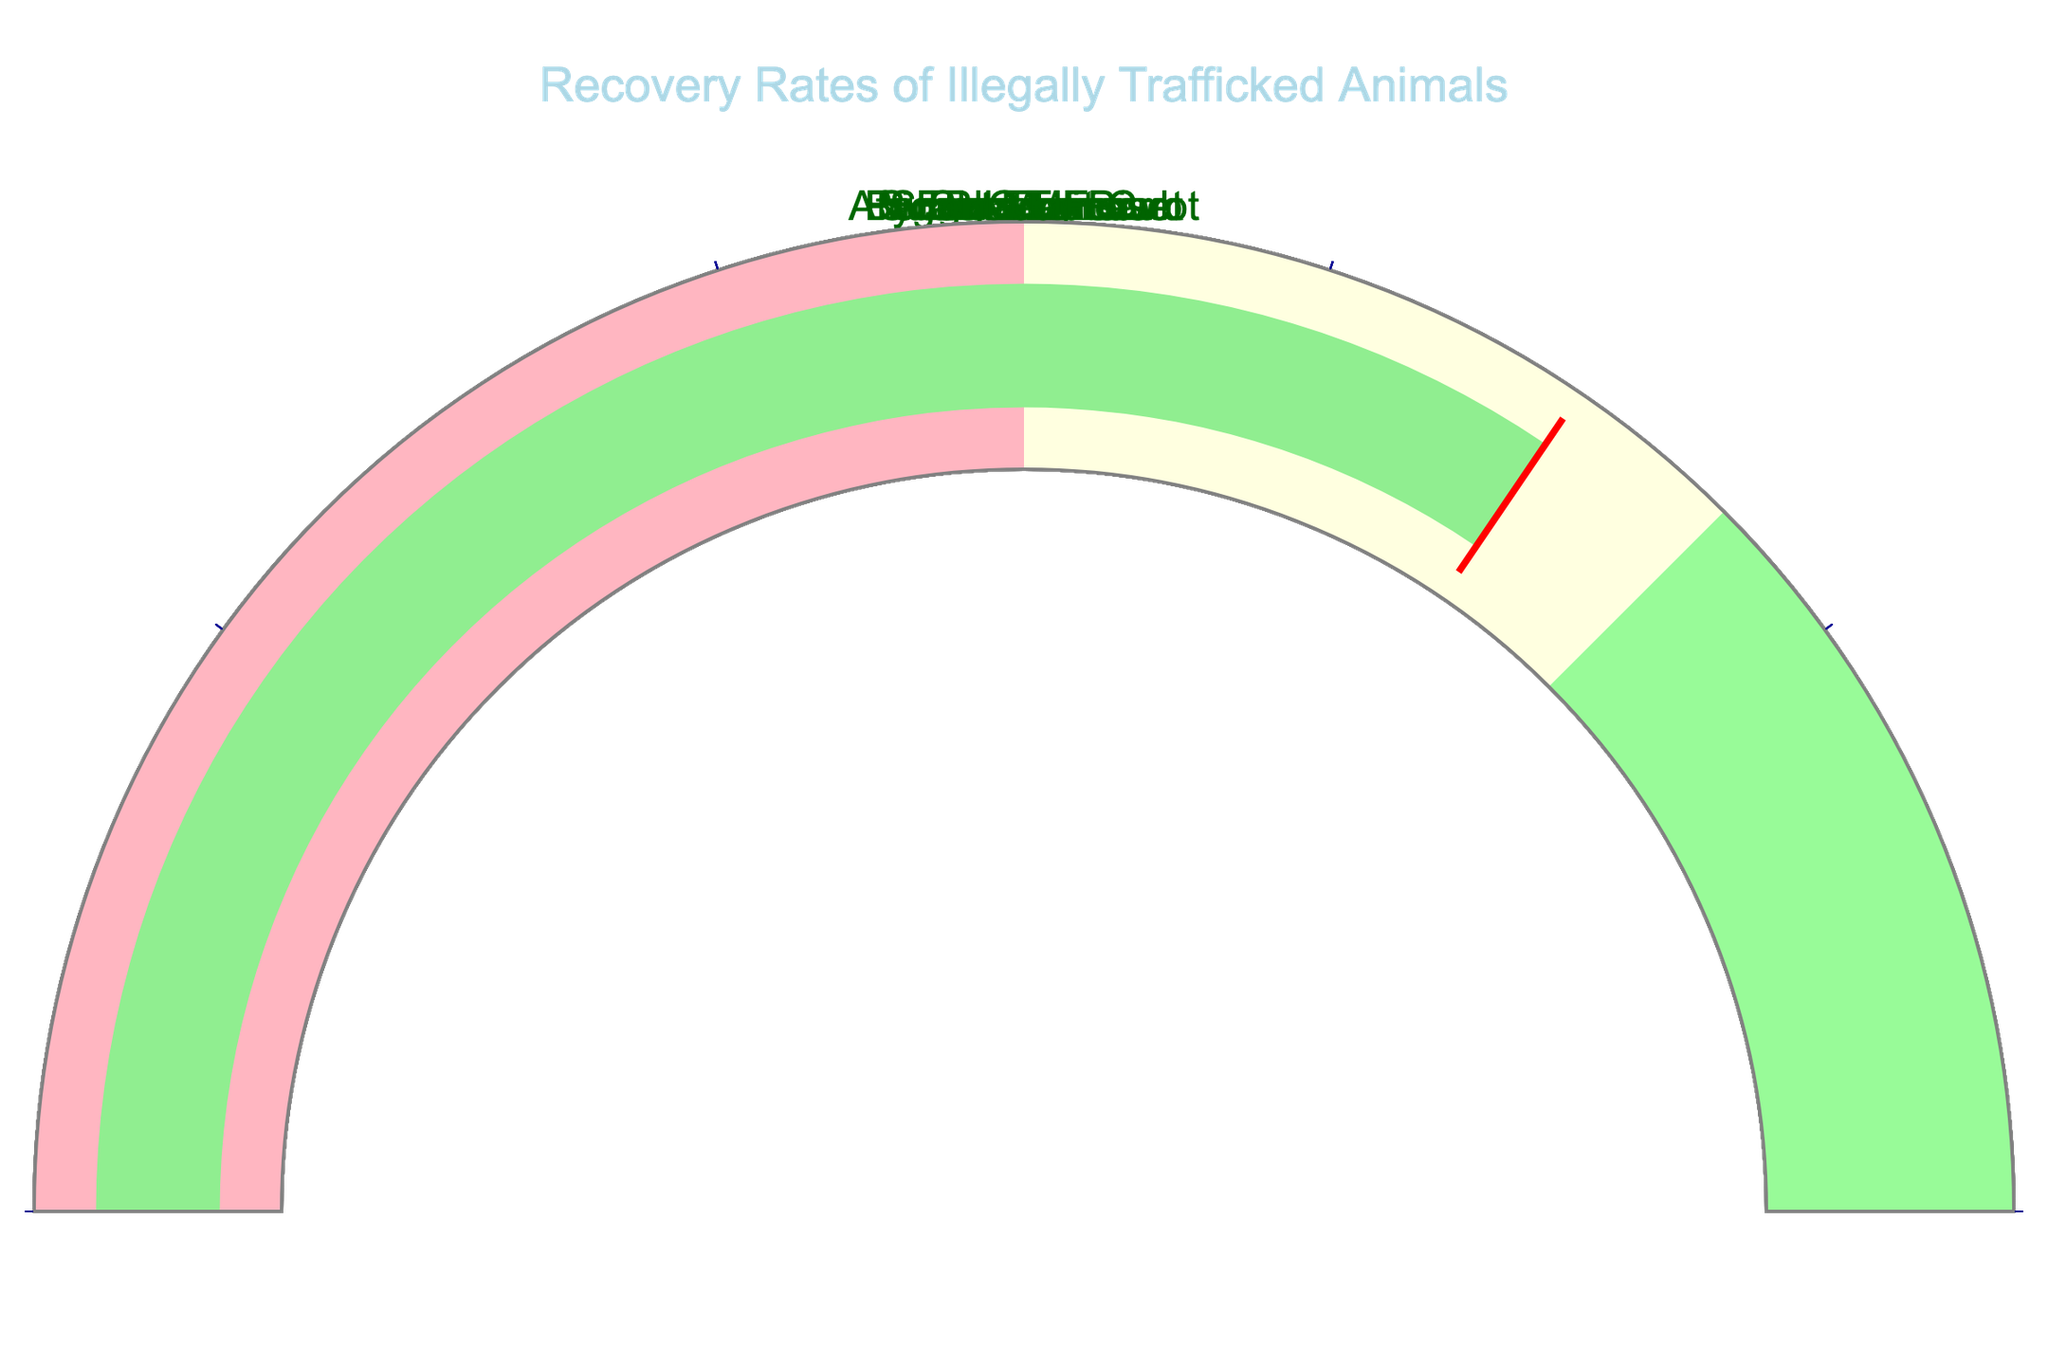Which species has the highest recovery rate? The gauge chart indicates recovery rates for each species. By comparing all the values visually, the Sulcata Tortoise has the highest recovery rate, indicated by 89.
Answer: Sulcata Tortoise What is the average recovery rate of all the species? To find the average recovery rate, sum up all the recovery rates and divide by the number of species. The recovery rates are 78, 62, 55, 71, 83, 89, 76, 69. Summing these gives 583. There are 8 species in total. So the average recovery rate is 583/8.
Answer: 72.875 Which species has the lowest recovery rate? By examining the recovery rates displayed on the gauges, the Slow Loris has the lowest rate at 55.
Answer: Slow Loris How many species have a recovery rate greater than 75%? By checking each gauge, the species with recovery rates greater than 75 are: African Grey Parrot (78), Pygmy Marmoset (83), Sulcata Tortoise (89). So, there are 3 such species.
Answer: 3 What's the difference in recovery rates between the Bengal Tiger Cub and the Fennec Fox? The recovery rate of the Bengal Tiger Cub is 71 and the Fennec Fox is 69. Subtracting 69 from 71 gives the difference.
Answer: 2 What is the combined recovery rate of the Scarlet Macaw and Pygmy Marmoset? The recovery rate of the Scarlet Macaw is 76 and the Pygmy Marmoset is 83. Adding these together gives a combined recovery rate.
Answer: 159 Are more than half of the species recovering at a rate greater than 60%? To determine this, count the species with rates over 60: African Grey Parrot, Pangolin, Bengal Tiger Cub, Pygmy Marmoset, Sulcata Tortoise, Scarlet Macaw, and Fennec Fox. This totals 7 out of 8 species, which is more than half.
Answer: Yes Which recovery rate range is not represented by any species? (0-50, 50-75, 75-100) By inspecting the recovery rates, all species fall in either the 50-75 or 75-100 range. No species have a recovery rate in the 0-50 range.
Answer: 0-50 What is the median recovery rate of the mentioned species? To find the median, organize the recovery rates in ascending order: 55, 62, 69, 71, 76, 78, 83, 89. With 8 species, the median is the average of the 4th and 5th values (71 and 76). So, the median recovery rate is (71 + 76) / 2.
Answer: 73.5 